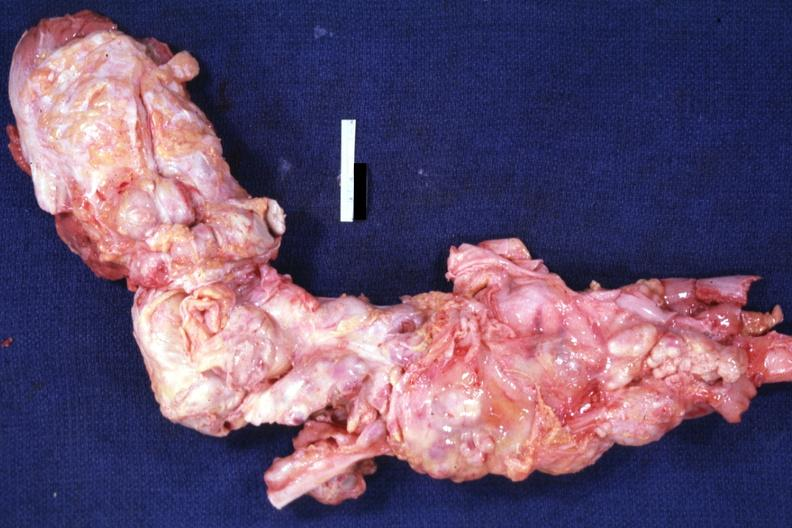what is present?
Answer the question using a single word or phrase. Hodgkins disease 